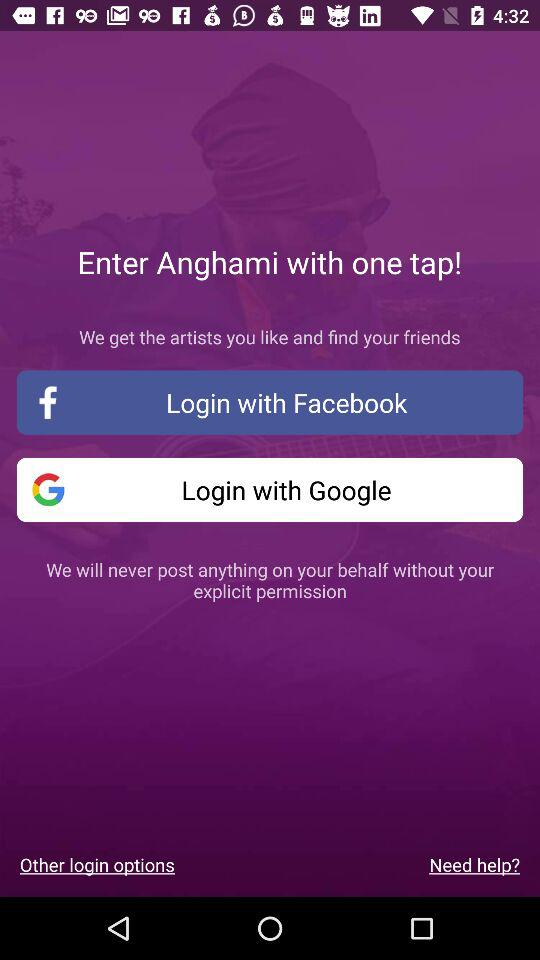What is the application name? The application name is "Anghami". 